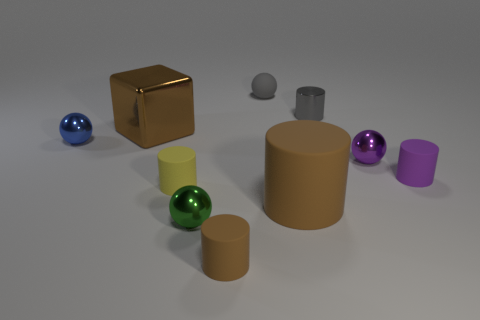Do the big rubber cylinder and the large shiny cube have the same color?
Offer a terse response. Yes. Does the big thing that is to the left of the small yellow thing have the same color as the big matte cylinder?
Provide a succinct answer. Yes. There is a big matte object that is the same color as the block; what is its shape?
Your answer should be very brief. Cylinder. There is a rubber cylinder that is the same size as the brown metal object; what color is it?
Keep it short and to the point. Brown. Are there any cylinders that have the same color as the cube?
Keep it short and to the point. Yes. What is the material of the big brown cylinder?
Offer a very short reply. Rubber. How many yellow rubber cylinders are there?
Offer a terse response. 1. There is a big block that is in front of the gray matte sphere; is it the same color as the large thing that is right of the small matte ball?
Offer a very short reply. Yes. There is a shiny object that is the same color as the large matte cylinder; what size is it?
Your answer should be very brief. Large. How many other objects are there of the same size as the purple ball?
Provide a short and direct response. 7. 